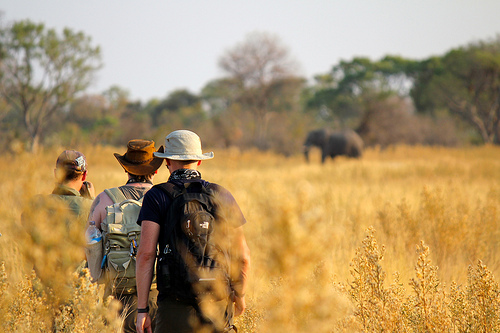How big is the backpack? The backpack is large. 